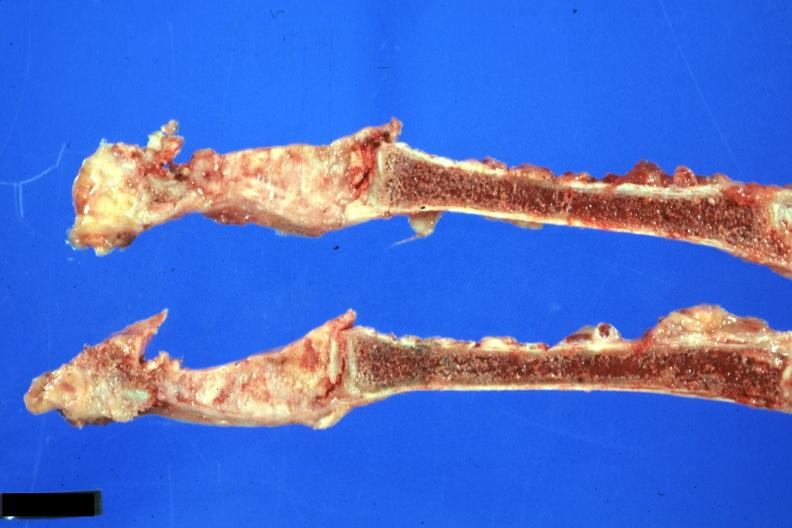does this image show sternum saggital section obvious neoplasm from lung scar carcinoma?
Answer the question using a single word or phrase. Yes 